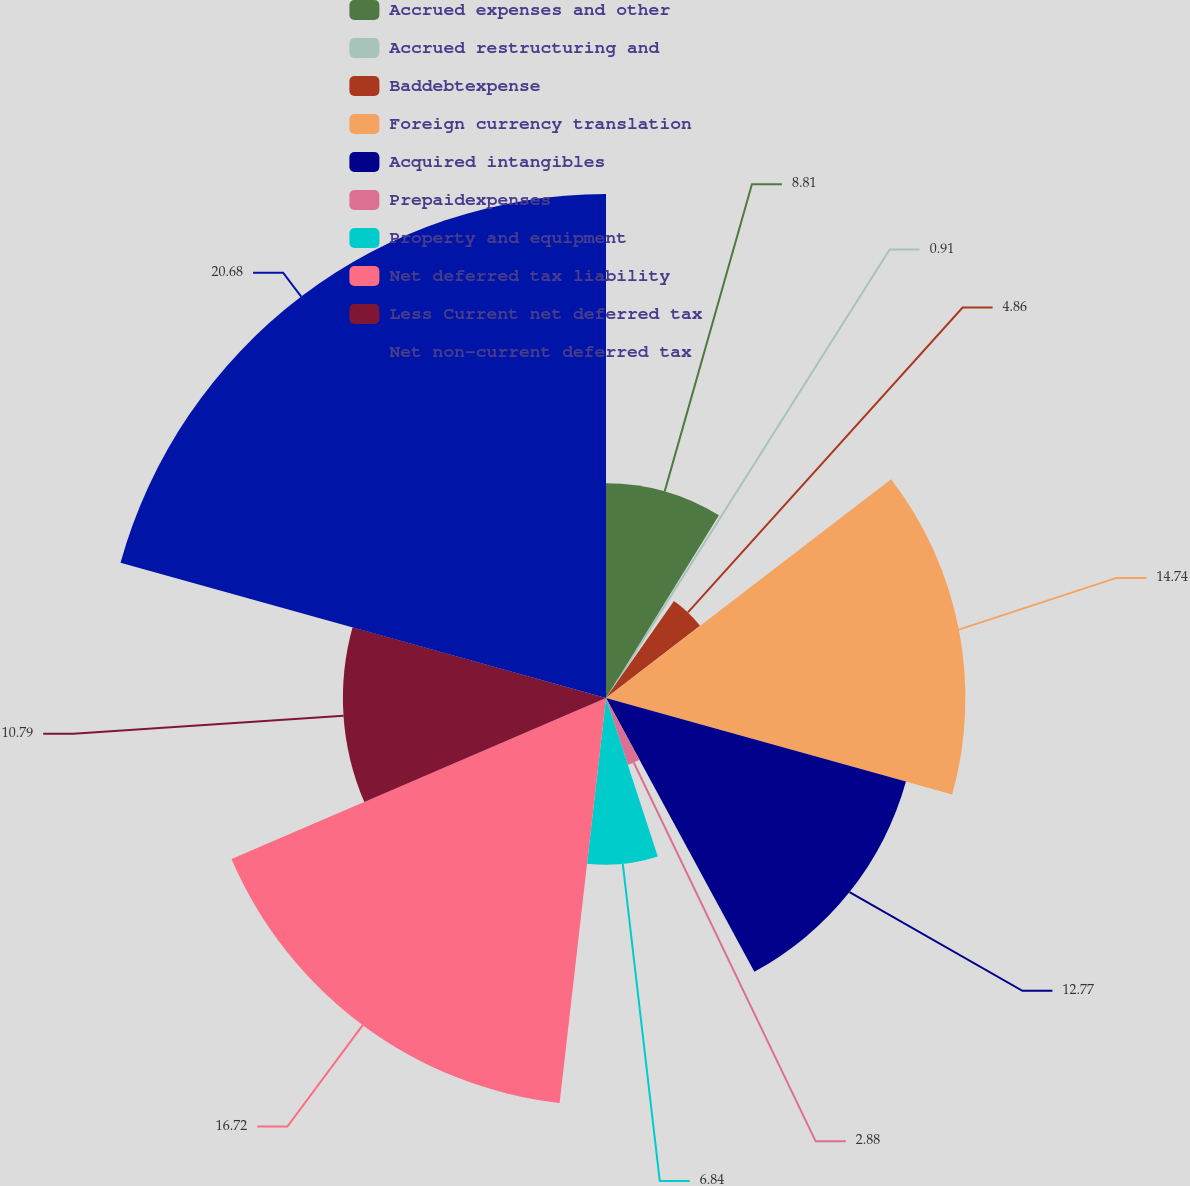Convert chart to OTSL. <chart><loc_0><loc_0><loc_500><loc_500><pie_chart><fcel>Accrued expenses and other<fcel>Accrued restructuring and<fcel>Baddebtexpense<fcel>Foreign currency translation<fcel>Acquired intangibles<fcel>Prepaidexpenses<fcel>Property and equipment<fcel>Net deferred tax liability<fcel>Less Current net deferred tax<fcel>Net non-current deferred tax<nl><fcel>8.81%<fcel>0.91%<fcel>4.86%<fcel>14.74%<fcel>12.77%<fcel>2.88%<fcel>6.84%<fcel>16.72%<fcel>10.79%<fcel>20.67%<nl></chart> 